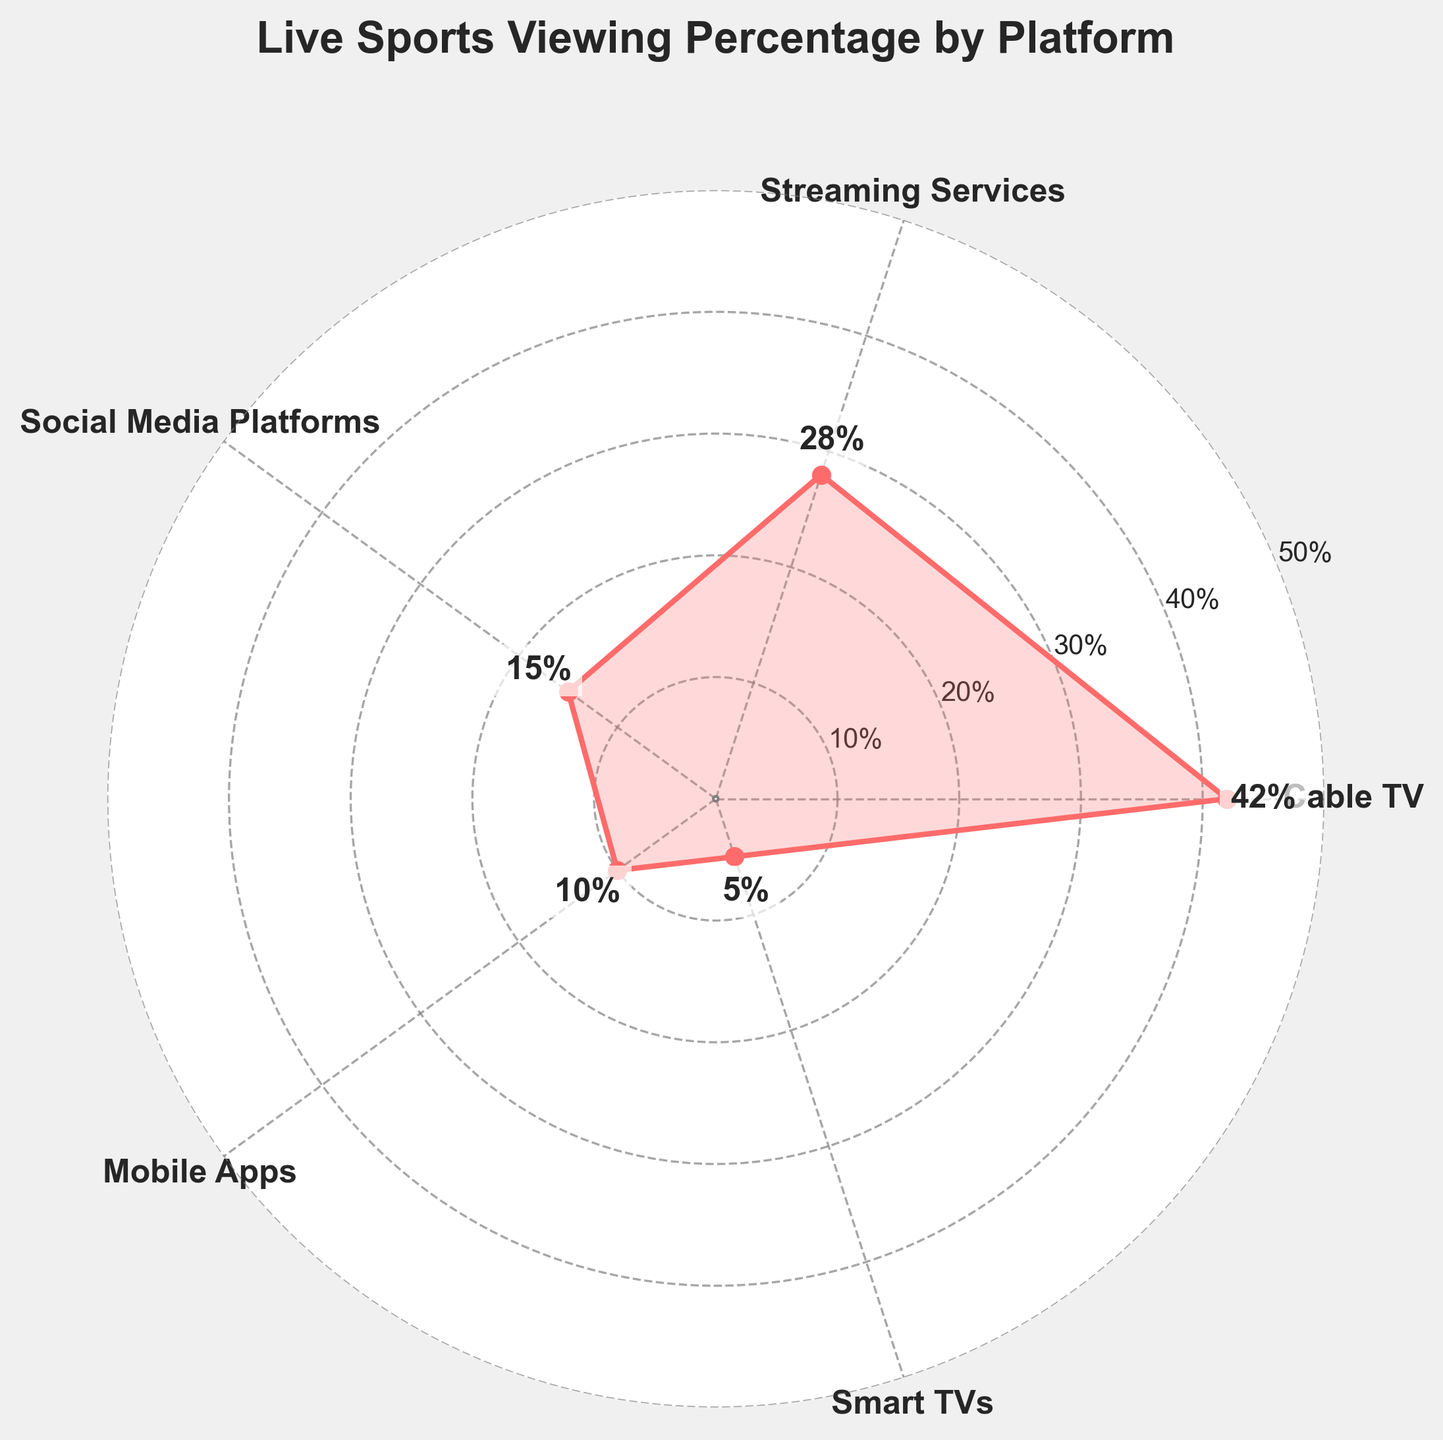What is the percentage of viewers watching live sports events on Cable TV? The angle corresponding to Cable TV shows a percentage of 42%.
Answer: 42% Which platform has the least percentage of viewers watching live sports events? The angle corresponding to Smart TVs shows the smallest percentage, which is 5%.
Answer: Smart TVs What's the range of percentages shown in the chart? The smallest value is 5% (Smart TVs) and the largest is 42% (Cable TV). The range is 42% - 5% = 37%.
Answer: 37% How many platforms are included in the chart? By counting the number of different platform labels around the polar plot, we determine there are 5 platforms listed.
Answer: 5 What is the total percentage of viewers watching live sports events on mobile apps and social media platforms combined? The percentage for mobile apps is 10% and for social media platforms is 15%. Adding these percentages together, 10% + 15% = 25%.
Answer: 25% Which platform has a higher percentage of viewers, Streaming Services or Mobile Apps? The angle corresponding to Streaming Services shows 28%, while the angle for Mobile Apps shows 10%. Therefore, Streaming Services have a higher percentage.
Answer: Streaming Services What is the average percentage of viewers across all platforms? Add all the percentages: \(42\% + 28\% + 15\% + 10\% + 5\%\), which equals 100%. Divide by the number of platforms (5): \(\frac{100}{5} = 20\%\).
Answer: 20% If the percentage of viewers on Cable TV decreases by 10%, how much would it be? The current percentage for Cable TV is 42%. If it decreases by 10%, the new percentage would be 42% - 10% = 32%.
Answer: 32% Which platform has viewers that are nearly double the percentage of those on Smart TVs? The percentage for Smart TVs is 5%; nearly double (i.e., 10%) corresponds to Mobile Apps.
Answer: Mobile Apps What two platforms combined account for more than half of the total viewership? The percentages for Cable TV and Streaming Services are 42% and 28%, respectively. Together, they sum up to 70%, which is more than half (50%) of the total viewership.
Answer: Cable TV and Streaming Services 